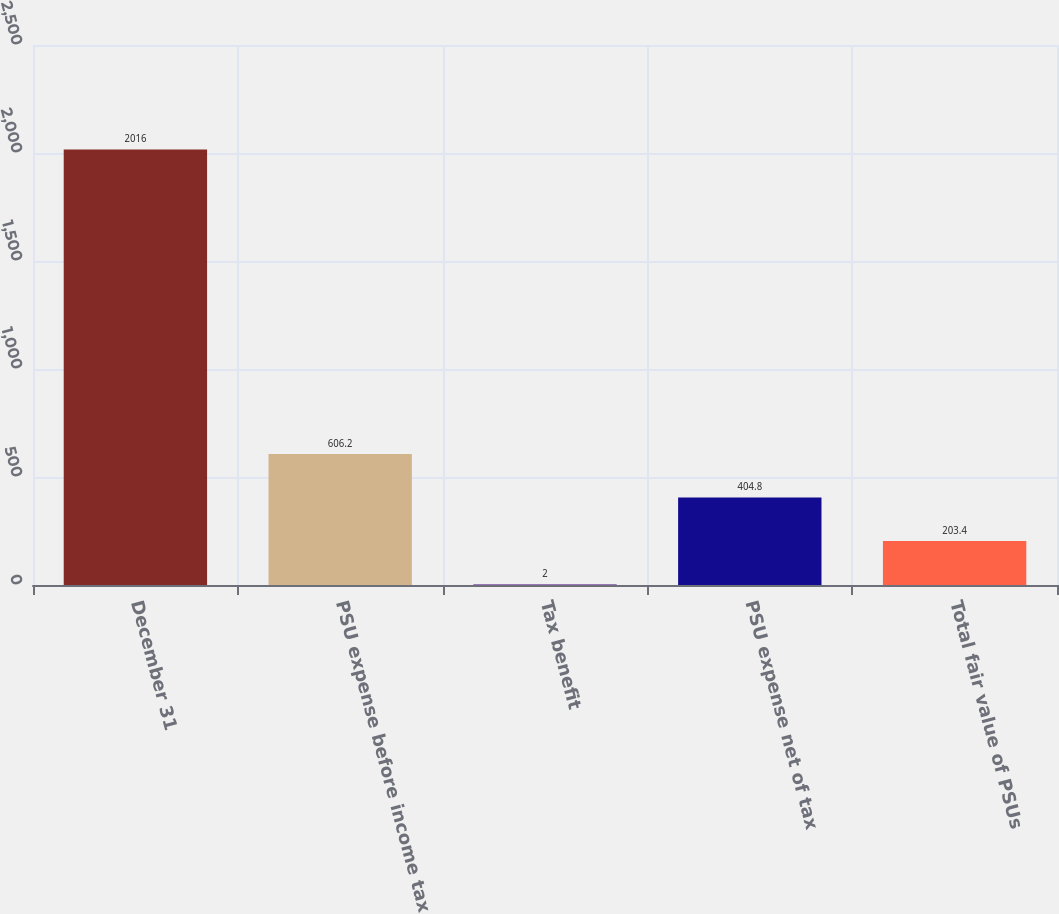Convert chart. <chart><loc_0><loc_0><loc_500><loc_500><bar_chart><fcel>December 31<fcel>PSU expense before income tax<fcel>Tax benefit<fcel>PSU expense net of tax<fcel>Total fair value of PSUs<nl><fcel>2016<fcel>606.2<fcel>2<fcel>404.8<fcel>203.4<nl></chart> 